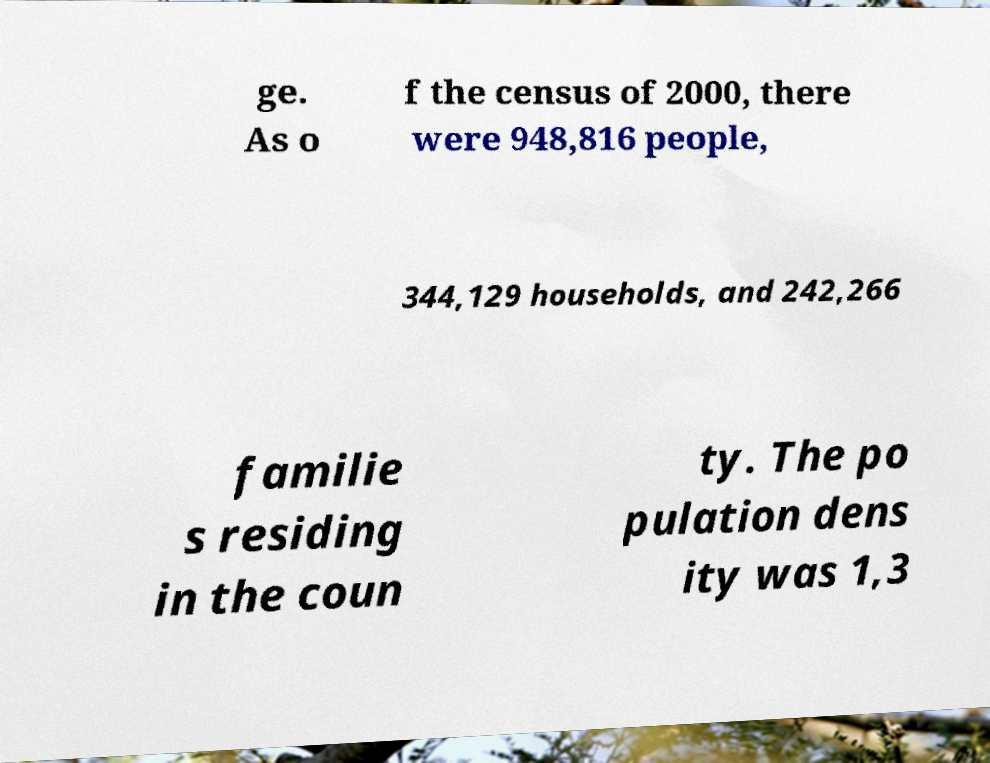There's text embedded in this image that I need extracted. Can you transcribe it verbatim? ge. As o f the census of 2000, there were 948,816 people, 344,129 households, and 242,266 familie s residing in the coun ty. The po pulation dens ity was 1,3 